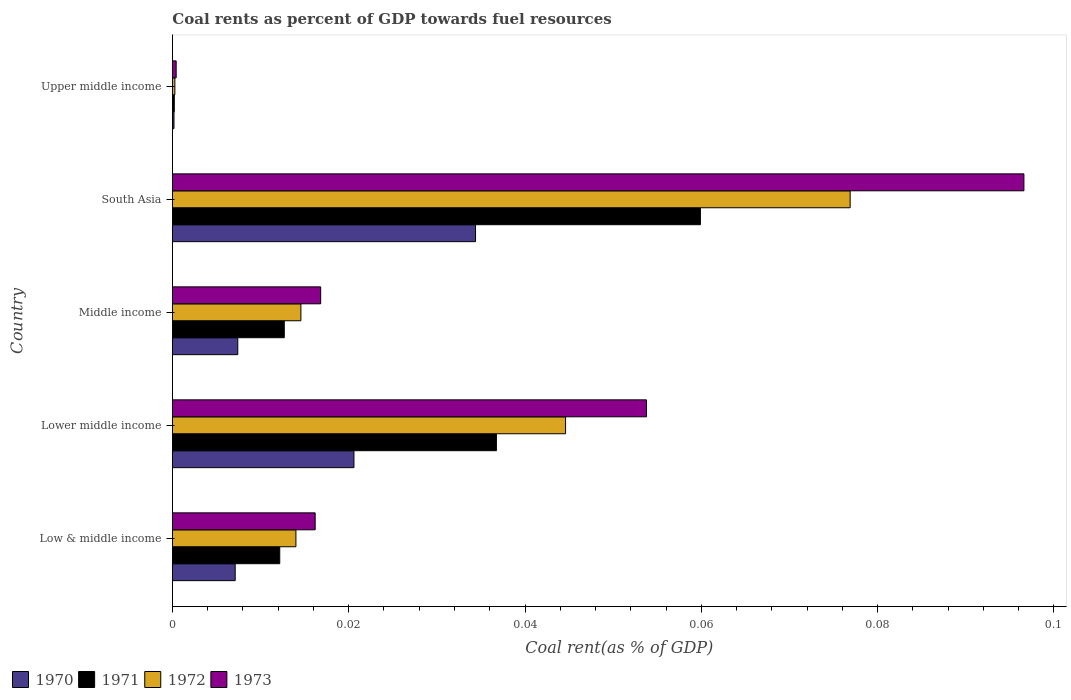How many different coloured bars are there?
Give a very brief answer. 4. In how many cases, is the number of bars for a given country not equal to the number of legend labels?
Your answer should be compact. 0. What is the coal rent in 1973 in Lower middle income?
Provide a succinct answer. 0.05. Across all countries, what is the maximum coal rent in 1970?
Offer a terse response. 0.03. Across all countries, what is the minimum coal rent in 1973?
Ensure brevity in your answer.  0. In which country was the coal rent in 1972 maximum?
Provide a short and direct response. South Asia. In which country was the coal rent in 1971 minimum?
Give a very brief answer. Upper middle income. What is the total coal rent in 1970 in the graph?
Give a very brief answer. 0.07. What is the difference between the coal rent in 1970 in Low & middle income and that in South Asia?
Offer a very short reply. -0.03. What is the difference between the coal rent in 1972 in Lower middle income and the coal rent in 1971 in Middle income?
Ensure brevity in your answer.  0.03. What is the average coal rent in 1973 per country?
Your response must be concise. 0.04. What is the difference between the coal rent in 1973 and coal rent in 1971 in Lower middle income?
Provide a short and direct response. 0.02. In how many countries, is the coal rent in 1971 greater than 0.096 %?
Offer a terse response. 0. What is the ratio of the coal rent in 1972 in Low & middle income to that in South Asia?
Make the answer very short. 0.18. Is the difference between the coal rent in 1973 in Lower middle income and South Asia greater than the difference between the coal rent in 1971 in Lower middle income and South Asia?
Provide a short and direct response. No. What is the difference between the highest and the second highest coal rent in 1971?
Offer a terse response. 0.02. What is the difference between the highest and the lowest coal rent in 1972?
Give a very brief answer. 0.08. Is it the case that in every country, the sum of the coal rent in 1970 and coal rent in 1972 is greater than the sum of coal rent in 1973 and coal rent in 1971?
Your answer should be very brief. No. What does the 4th bar from the bottom in Middle income represents?
Give a very brief answer. 1973. Is it the case that in every country, the sum of the coal rent in 1973 and coal rent in 1971 is greater than the coal rent in 1972?
Your answer should be very brief. Yes. Are the values on the major ticks of X-axis written in scientific E-notation?
Your response must be concise. No. How are the legend labels stacked?
Give a very brief answer. Horizontal. What is the title of the graph?
Provide a short and direct response. Coal rents as percent of GDP towards fuel resources. Does "1970" appear as one of the legend labels in the graph?
Offer a very short reply. Yes. What is the label or title of the X-axis?
Make the answer very short. Coal rent(as % of GDP). What is the label or title of the Y-axis?
Offer a terse response. Country. What is the Coal rent(as % of GDP) of 1970 in Low & middle income?
Make the answer very short. 0.01. What is the Coal rent(as % of GDP) in 1971 in Low & middle income?
Provide a short and direct response. 0.01. What is the Coal rent(as % of GDP) of 1972 in Low & middle income?
Your answer should be compact. 0.01. What is the Coal rent(as % of GDP) of 1973 in Low & middle income?
Offer a terse response. 0.02. What is the Coal rent(as % of GDP) in 1970 in Lower middle income?
Make the answer very short. 0.02. What is the Coal rent(as % of GDP) in 1971 in Lower middle income?
Offer a very short reply. 0.04. What is the Coal rent(as % of GDP) in 1972 in Lower middle income?
Ensure brevity in your answer.  0.04. What is the Coal rent(as % of GDP) of 1973 in Lower middle income?
Give a very brief answer. 0.05. What is the Coal rent(as % of GDP) of 1970 in Middle income?
Your response must be concise. 0.01. What is the Coal rent(as % of GDP) of 1971 in Middle income?
Give a very brief answer. 0.01. What is the Coal rent(as % of GDP) in 1972 in Middle income?
Keep it short and to the point. 0.01. What is the Coal rent(as % of GDP) in 1973 in Middle income?
Make the answer very short. 0.02. What is the Coal rent(as % of GDP) of 1970 in South Asia?
Your response must be concise. 0.03. What is the Coal rent(as % of GDP) of 1971 in South Asia?
Ensure brevity in your answer.  0.06. What is the Coal rent(as % of GDP) in 1972 in South Asia?
Keep it short and to the point. 0.08. What is the Coal rent(as % of GDP) of 1973 in South Asia?
Ensure brevity in your answer.  0.1. What is the Coal rent(as % of GDP) in 1970 in Upper middle income?
Make the answer very short. 0. What is the Coal rent(as % of GDP) of 1971 in Upper middle income?
Provide a short and direct response. 0. What is the Coal rent(as % of GDP) in 1972 in Upper middle income?
Keep it short and to the point. 0. What is the Coal rent(as % of GDP) of 1973 in Upper middle income?
Make the answer very short. 0. Across all countries, what is the maximum Coal rent(as % of GDP) in 1970?
Ensure brevity in your answer.  0.03. Across all countries, what is the maximum Coal rent(as % of GDP) of 1971?
Give a very brief answer. 0.06. Across all countries, what is the maximum Coal rent(as % of GDP) of 1972?
Ensure brevity in your answer.  0.08. Across all countries, what is the maximum Coal rent(as % of GDP) of 1973?
Your answer should be very brief. 0.1. Across all countries, what is the minimum Coal rent(as % of GDP) of 1970?
Your response must be concise. 0. Across all countries, what is the minimum Coal rent(as % of GDP) in 1971?
Give a very brief answer. 0. Across all countries, what is the minimum Coal rent(as % of GDP) in 1972?
Keep it short and to the point. 0. Across all countries, what is the minimum Coal rent(as % of GDP) of 1973?
Make the answer very short. 0. What is the total Coal rent(as % of GDP) in 1970 in the graph?
Ensure brevity in your answer.  0.07. What is the total Coal rent(as % of GDP) of 1971 in the graph?
Your answer should be compact. 0.12. What is the total Coal rent(as % of GDP) of 1972 in the graph?
Your answer should be compact. 0.15. What is the total Coal rent(as % of GDP) of 1973 in the graph?
Offer a terse response. 0.18. What is the difference between the Coal rent(as % of GDP) in 1970 in Low & middle income and that in Lower middle income?
Provide a succinct answer. -0.01. What is the difference between the Coal rent(as % of GDP) of 1971 in Low & middle income and that in Lower middle income?
Keep it short and to the point. -0.02. What is the difference between the Coal rent(as % of GDP) of 1972 in Low & middle income and that in Lower middle income?
Make the answer very short. -0.03. What is the difference between the Coal rent(as % of GDP) of 1973 in Low & middle income and that in Lower middle income?
Offer a terse response. -0.04. What is the difference between the Coal rent(as % of GDP) in 1970 in Low & middle income and that in Middle income?
Your answer should be very brief. -0. What is the difference between the Coal rent(as % of GDP) of 1971 in Low & middle income and that in Middle income?
Provide a succinct answer. -0. What is the difference between the Coal rent(as % of GDP) in 1972 in Low & middle income and that in Middle income?
Your answer should be very brief. -0. What is the difference between the Coal rent(as % of GDP) of 1973 in Low & middle income and that in Middle income?
Your response must be concise. -0. What is the difference between the Coal rent(as % of GDP) of 1970 in Low & middle income and that in South Asia?
Keep it short and to the point. -0.03. What is the difference between the Coal rent(as % of GDP) of 1971 in Low & middle income and that in South Asia?
Keep it short and to the point. -0.05. What is the difference between the Coal rent(as % of GDP) in 1972 in Low & middle income and that in South Asia?
Your answer should be compact. -0.06. What is the difference between the Coal rent(as % of GDP) in 1973 in Low & middle income and that in South Asia?
Offer a very short reply. -0.08. What is the difference between the Coal rent(as % of GDP) in 1970 in Low & middle income and that in Upper middle income?
Ensure brevity in your answer.  0.01. What is the difference between the Coal rent(as % of GDP) in 1971 in Low & middle income and that in Upper middle income?
Your response must be concise. 0.01. What is the difference between the Coal rent(as % of GDP) in 1972 in Low & middle income and that in Upper middle income?
Keep it short and to the point. 0.01. What is the difference between the Coal rent(as % of GDP) in 1973 in Low & middle income and that in Upper middle income?
Ensure brevity in your answer.  0.02. What is the difference between the Coal rent(as % of GDP) of 1970 in Lower middle income and that in Middle income?
Make the answer very short. 0.01. What is the difference between the Coal rent(as % of GDP) in 1971 in Lower middle income and that in Middle income?
Give a very brief answer. 0.02. What is the difference between the Coal rent(as % of GDP) of 1973 in Lower middle income and that in Middle income?
Give a very brief answer. 0.04. What is the difference between the Coal rent(as % of GDP) of 1970 in Lower middle income and that in South Asia?
Provide a succinct answer. -0.01. What is the difference between the Coal rent(as % of GDP) of 1971 in Lower middle income and that in South Asia?
Offer a terse response. -0.02. What is the difference between the Coal rent(as % of GDP) in 1972 in Lower middle income and that in South Asia?
Your answer should be very brief. -0.03. What is the difference between the Coal rent(as % of GDP) of 1973 in Lower middle income and that in South Asia?
Keep it short and to the point. -0.04. What is the difference between the Coal rent(as % of GDP) in 1970 in Lower middle income and that in Upper middle income?
Keep it short and to the point. 0.02. What is the difference between the Coal rent(as % of GDP) in 1971 in Lower middle income and that in Upper middle income?
Your answer should be compact. 0.04. What is the difference between the Coal rent(as % of GDP) in 1972 in Lower middle income and that in Upper middle income?
Provide a succinct answer. 0.04. What is the difference between the Coal rent(as % of GDP) of 1973 in Lower middle income and that in Upper middle income?
Offer a very short reply. 0.05. What is the difference between the Coal rent(as % of GDP) in 1970 in Middle income and that in South Asia?
Your response must be concise. -0.03. What is the difference between the Coal rent(as % of GDP) of 1971 in Middle income and that in South Asia?
Your response must be concise. -0.05. What is the difference between the Coal rent(as % of GDP) in 1972 in Middle income and that in South Asia?
Provide a short and direct response. -0.06. What is the difference between the Coal rent(as % of GDP) in 1973 in Middle income and that in South Asia?
Your response must be concise. -0.08. What is the difference between the Coal rent(as % of GDP) of 1970 in Middle income and that in Upper middle income?
Make the answer very short. 0.01. What is the difference between the Coal rent(as % of GDP) of 1971 in Middle income and that in Upper middle income?
Ensure brevity in your answer.  0.01. What is the difference between the Coal rent(as % of GDP) of 1972 in Middle income and that in Upper middle income?
Offer a very short reply. 0.01. What is the difference between the Coal rent(as % of GDP) of 1973 in Middle income and that in Upper middle income?
Your response must be concise. 0.02. What is the difference between the Coal rent(as % of GDP) of 1970 in South Asia and that in Upper middle income?
Offer a terse response. 0.03. What is the difference between the Coal rent(as % of GDP) in 1971 in South Asia and that in Upper middle income?
Provide a succinct answer. 0.06. What is the difference between the Coal rent(as % of GDP) in 1972 in South Asia and that in Upper middle income?
Ensure brevity in your answer.  0.08. What is the difference between the Coal rent(as % of GDP) of 1973 in South Asia and that in Upper middle income?
Provide a succinct answer. 0.1. What is the difference between the Coal rent(as % of GDP) in 1970 in Low & middle income and the Coal rent(as % of GDP) in 1971 in Lower middle income?
Your response must be concise. -0.03. What is the difference between the Coal rent(as % of GDP) of 1970 in Low & middle income and the Coal rent(as % of GDP) of 1972 in Lower middle income?
Make the answer very short. -0.04. What is the difference between the Coal rent(as % of GDP) of 1970 in Low & middle income and the Coal rent(as % of GDP) of 1973 in Lower middle income?
Ensure brevity in your answer.  -0.05. What is the difference between the Coal rent(as % of GDP) in 1971 in Low & middle income and the Coal rent(as % of GDP) in 1972 in Lower middle income?
Provide a short and direct response. -0.03. What is the difference between the Coal rent(as % of GDP) in 1971 in Low & middle income and the Coal rent(as % of GDP) in 1973 in Lower middle income?
Provide a succinct answer. -0.04. What is the difference between the Coal rent(as % of GDP) of 1972 in Low & middle income and the Coal rent(as % of GDP) of 1973 in Lower middle income?
Your answer should be very brief. -0.04. What is the difference between the Coal rent(as % of GDP) of 1970 in Low & middle income and the Coal rent(as % of GDP) of 1971 in Middle income?
Your response must be concise. -0.01. What is the difference between the Coal rent(as % of GDP) of 1970 in Low & middle income and the Coal rent(as % of GDP) of 1972 in Middle income?
Your response must be concise. -0.01. What is the difference between the Coal rent(as % of GDP) in 1970 in Low & middle income and the Coal rent(as % of GDP) in 1973 in Middle income?
Provide a short and direct response. -0.01. What is the difference between the Coal rent(as % of GDP) of 1971 in Low & middle income and the Coal rent(as % of GDP) of 1972 in Middle income?
Give a very brief answer. -0. What is the difference between the Coal rent(as % of GDP) in 1971 in Low & middle income and the Coal rent(as % of GDP) in 1973 in Middle income?
Provide a succinct answer. -0. What is the difference between the Coal rent(as % of GDP) in 1972 in Low & middle income and the Coal rent(as % of GDP) in 1973 in Middle income?
Your answer should be very brief. -0. What is the difference between the Coal rent(as % of GDP) in 1970 in Low & middle income and the Coal rent(as % of GDP) in 1971 in South Asia?
Your answer should be very brief. -0.05. What is the difference between the Coal rent(as % of GDP) of 1970 in Low & middle income and the Coal rent(as % of GDP) of 1972 in South Asia?
Ensure brevity in your answer.  -0.07. What is the difference between the Coal rent(as % of GDP) in 1970 in Low & middle income and the Coal rent(as % of GDP) in 1973 in South Asia?
Offer a terse response. -0.09. What is the difference between the Coal rent(as % of GDP) of 1971 in Low & middle income and the Coal rent(as % of GDP) of 1972 in South Asia?
Offer a very short reply. -0.06. What is the difference between the Coal rent(as % of GDP) in 1971 in Low & middle income and the Coal rent(as % of GDP) in 1973 in South Asia?
Make the answer very short. -0.08. What is the difference between the Coal rent(as % of GDP) in 1972 in Low & middle income and the Coal rent(as % of GDP) in 1973 in South Asia?
Ensure brevity in your answer.  -0.08. What is the difference between the Coal rent(as % of GDP) of 1970 in Low & middle income and the Coal rent(as % of GDP) of 1971 in Upper middle income?
Offer a terse response. 0.01. What is the difference between the Coal rent(as % of GDP) of 1970 in Low & middle income and the Coal rent(as % of GDP) of 1972 in Upper middle income?
Your answer should be compact. 0.01. What is the difference between the Coal rent(as % of GDP) of 1970 in Low & middle income and the Coal rent(as % of GDP) of 1973 in Upper middle income?
Your answer should be very brief. 0.01. What is the difference between the Coal rent(as % of GDP) in 1971 in Low & middle income and the Coal rent(as % of GDP) in 1972 in Upper middle income?
Provide a short and direct response. 0.01. What is the difference between the Coal rent(as % of GDP) in 1971 in Low & middle income and the Coal rent(as % of GDP) in 1973 in Upper middle income?
Your answer should be very brief. 0.01. What is the difference between the Coal rent(as % of GDP) in 1972 in Low & middle income and the Coal rent(as % of GDP) in 1973 in Upper middle income?
Provide a short and direct response. 0.01. What is the difference between the Coal rent(as % of GDP) of 1970 in Lower middle income and the Coal rent(as % of GDP) of 1971 in Middle income?
Offer a terse response. 0.01. What is the difference between the Coal rent(as % of GDP) in 1970 in Lower middle income and the Coal rent(as % of GDP) in 1972 in Middle income?
Make the answer very short. 0.01. What is the difference between the Coal rent(as % of GDP) in 1970 in Lower middle income and the Coal rent(as % of GDP) in 1973 in Middle income?
Keep it short and to the point. 0. What is the difference between the Coal rent(as % of GDP) in 1971 in Lower middle income and the Coal rent(as % of GDP) in 1972 in Middle income?
Give a very brief answer. 0.02. What is the difference between the Coal rent(as % of GDP) in 1971 in Lower middle income and the Coal rent(as % of GDP) in 1973 in Middle income?
Your answer should be very brief. 0.02. What is the difference between the Coal rent(as % of GDP) in 1972 in Lower middle income and the Coal rent(as % of GDP) in 1973 in Middle income?
Offer a terse response. 0.03. What is the difference between the Coal rent(as % of GDP) of 1970 in Lower middle income and the Coal rent(as % of GDP) of 1971 in South Asia?
Your answer should be compact. -0.04. What is the difference between the Coal rent(as % of GDP) in 1970 in Lower middle income and the Coal rent(as % of GDP) in 1972 in South Asia?
Your answer should be compact. -0.06. What is the difference between the Coal rent(as % of GDP) of 1970 in Lower middle income and the Coal rent(as % of GDP) of 1973 in South Asia?
Your response must be concise. -0.08. What is the difference between the Coal rent(as % of GDP) of 1971 in Lower middle income and the Coal rent(as % of GDP) of 1972 in South Asia?
Your answer should be compact. -0.04. What is the difference between the Coal rent(as % of GDP) of 1971 in Lower middle income and the Coal rent(as % of GDP) of 1973 in South Asia?
Keep it short and to the point. -0.06. What is the difference between the Coal rent(as % of GDP) in 1972 in Lower middle income and the Coal rent(as % of GDP) in 1973 in South Asia?
Offer a terse response. -0.05. What is the difference between the Coal rent(as % of GDP) of 1970 in Lower middle income and the Coal rent(as % of GDP) of 1971 in Upper middle income?
Ensure brevity in your answer.  0.02. What is the difference between the Coal rent(as % of GDP) of 1970 in Lower middle income and the Coal rent(as % of GDP) of 1972 in Upper middle income?
Offer a terse response. 0.02. What is the difference between the Coal rent(as % of GDP) in 1970 in Lower middle income and the Coal rent(as % of GDP) in 1973 in Upper middle income?
Provide a short and direct response. 0.02. What is the difference between the Coal rent(as % of GDP) in 1971 in Lower middle income and the Coal rent(as % of GDP) in 1972 in Upper middle income?
Provide a succinct answer. 0.04. What is the difference between the Coal rent(as % of GDP) in 1971 in Lower middle income and the Coal rent(as % of GDP) in 1973 in Upper middle income?
Ensure brevity in your answer.  0.04. What is the difference between the Coal rent(as % of GDP) of 1972 in Lower middle income and the Coal rent(as % of GDP) of 1973 in Upper middle income?
Make the answer very short. 0.04. What is the difference between the Coal rent(as % of GDP) in 1970 in Middle income and the Coal rent(as % of GDP) in 1971 in South Asia?
Give a very brief answer. -0.05. What is the difference between the Coal rent(as % of GDP) in 1970 in Middle income and the Coal rent(as % of GDP) in 1972 in South Asia?
Provide a short and direct response. -0.07. What is the difference between the Coal rent(as % of GDP) in 1970 in Middle income and the Coal rent(as % of GDP) in 1973 in South Asia?
Your answer should be compact. -0.09. What is the difference between the Coal rent(as % of GDP) of 1971 in Middle income and the Coal rent(as % of GDP) of 1972 in South Asia?
Your answer should be compact. -0.06. What is the difference between the Coal rent(as % of GDP) of 1971 in Middle income and the Coal rent(as % of GDP) of 1973 in South Asia?
Your answer should be compact. -0.08. What is the difference between the Coal rent(as % of GDP) in 1972 in Middle income and the Coal rent(as % of GDP) in 1973 in South Asia?
Ensure brevity in your answer.  -0.08. What is the difference between the Coal rent(as % of GDP) in 1970 in Middle income and the Coal rent(as % of GDP) in 1971 in Upper middle income?
Ensure brevity in your answer.  0.01. What is the difference between the Coal rent(as % of GDP) in 1970 in Middle income and the Coal rent(as % of GDP) in 1972 in Upper middle income?
Give a very brief answer. 0.01. What is the difference between the Coal rent(as % of GDP) in 1970 in Middle income and the Coal rent(as % of GDP) in 1973 in Upper middle income?
Give a very brief answer. 0.01. What is the difference between the Coal rent(as % of GDP) in 1971 in Middle income and the Coal rent(as % of GDP) in 1972 in Upper middle income?
Keep it short and to the point. 0.01. What is the difference between the Coal rent(as % of GDP) in 1971 in Middle income and the Coal rent(as % of GDP) in 1973 in Upper middle income?
Make the answer very short. 0.01. What is the difference between the Coal rent(as % of GDP) in 1972 in Middle income and the Coal rent(as % of GDP) in 1973 in Upper middle income?
Offer a very short reply. 0.01. What is the difference between the Coal rent(as % of GDP) of 1970 in South Asia and the Coal rent(as % of GDP) of 1971 in Upper middle income?
Your answer should be compact. 0.03. What is the difference between the Coal rent(as % of GDP) in 1970 in South Asia and the Coal rent(as % of GDP) in 1972 in Upper middle income?
Your response must be concise. 0.03. What is the difference between the Coal rent(as % of GDP) of 1970 in South Asia and the Coal rent(as % of GDP) of 1973 in Upper middle income?
Ensure brevity in your answer.  0.03. What is the difference between the Coal rent(as % of GDP) of 1971 in South Asia and the Coal rent(as % of GDP) of 1972 in Upper middle income?
Your answer should be compact. 0.06. What is the difference between the Coal rent(as % of GDP) of 1971 in South Asia and the Coal rent(as % of GDP) of 1973 in Upper middle income?
Your response must be concise. 0.06. What is the difference between the Coal rent(as % of GDP) of 1972 in South Asia and the Coal rent(as % of GDP) of 1973 in Upper middle income?
Provide a succinct answer. 0.08. What is the average Coal rent(as % of GDP) in 1970 per country?
Make the answer very short. 0.01. What is the average Coal rent(as % of GDP) in 1971 per country?
Your answer should be compact. 0.02. What is the average Coal rent(as % of GDP) in 1972 per country?
Offer a terse response. 0.03. What is the average Coal rent(as % of GDP) in 1973 per country?
Ensure brevity in your answer.  0.04. What is the difference between the Coal rent(as % of GDP) of 1970 and Coal rent(as % of GDP) of 1971 in Low & middle income?
Give a very brief answer. -0.01. What is the difference between the Coal rent(as % of GDP) of 1970 and Coal rent(as % of GDP) of 1972 in Low & middle income?
Give a very brief answer. -0.01. What is the difference between the Coal rent(as % of GDP) in 1970 and Coal rent(as % of GDP) in 1973 in Low & middle income?
Provide a short and direct response. -0.01. What is the difference between the Coal rent(as % of GDP) in 1971 and Coal rent(as % of GDP) in 1972 in Low & middle income?
Offer a terse response. -0. What is the difference between the Coal rent(as % of GDP) of 1971 and Coal rent(as % of GDP) of 1973 in Low & middle income?
Make the answer very short. -0. What is the difference between the Coal rent(as % of GDP) in 1972 and Coal rent(as % of GDP) in 1973 in Low & middle income?
Your answer should be very brief. -0. What is the difference between the Coal rent(as % of GDP) of 1970 and Coal rent(as % of GDP) of 1971 in Lower middle income?
Provide a short and direct response. -0.02. What is the difference between the Coal rent(as % of GDP) in 1970 and Coal rent(as % of GDP) in 1972 in Lower middle income?
Give a very brief answer. -0.02. What is the difference between the Coal rent(as % of GDP) in 1970 and Coal rent(as % of GDP) in 1973 in Lower middle income?
Provide a succinct answer. -0.03. What is the difference between the Coal rent(as % of GDP) of 1971 and Coal rent(as % of GDP) of 1972 in Lower middle income?
Keep it short and to the point. -0.01. What is the difference between the Coal rent(as % of GDP) in 1971 and Coal rent(as % of GDP) in 1973 in Lower middle income?
Offer a very short reply. -0.02. What is the difference between the Coal rent(as % of GDP) in 1972 and Coal rent(as % of GDP) in 1973 in Lower middle income?
Offer a terse response. -0.01. What is the difference between the Coal rent(as % of GDP) of 1970 and Coal rent(as % of GDP) of 1971 in Middle income?
Provide a short and direct response. -0.01. What is the difference between the Coal rent(as % of GDP) of 1970 and Coal rent(as % of GDP) of 1972 in Middle income?
Offer a very short reply. -0.01. What is the difference between the Coal rent(as % of GDP) of 1970 and Coal rent(as % of GDP) of 1973 in Middle income?
Provide a succinct answer. -0.01. What is the difference between the Coal rent(as % of GDP) in 1971 and Coal rent(as % of GDP) in 1972 in Middle income?
Your answer should be very brief. -0. What is the difference between the Coal rent(as % of GDP) in 1971 and Coal rent(as % of GDP) in 1973 in Middle income?
Offer a terse response. -0. What is the difference between the Coal rent(as % of GDP) in 1972 and Coal rent(as % of GDP) in 1973 in Middle income?
Make the answer very short. -0. What is the difference between the Coal rent(as % of GDP) of 1970 and Coal rent(as % of GDP) of 1971 in South Asia?
Offer a very short reply. -0.03. What is the difference between the Coal rent(as % of GDP) of 1970 and Coal rent(as % of GDP) of 1972 in South Asia?
Ensure brevity in your answer.  -0.04. What is the difference between the Coal rent(as % of GDP) of 1970 and Coal rent(as % of GDP) of 1973 in South Asia?
Offer a very short reply. -0.06. What is the difference between the Coal rent(as % of GDP) of 1971 and Coal rent(as % of GDP) of 1972 in South Asia?
Offer a terse response. -0.02. What is the difference between the Coal rent(as % of GDP) of 1971 and Coal rent(as % of GDP) of 1973 in South Asia?
Provide a short and direct response. -0.04. What is the difference between the Coal rent(as % of GDP) of 1972 and Coal rent(as % of GDP) of 1973 in South Asia?
Offer a very short reply. -0.02. What is the difference between the Coal rent(as % of GDP) in 1970 and Coal rent(as % of GDP) in 1971 in Upper middle income?
Offer a terse response. -0. What is the difference between the Coal rent(as % of GDP) in 1970 and Coal rent(as % of GDP) in 1972 in Upper middle income?
Offer a very short reply. -0. What is the difference between the Coal rent(as % of GDP) of 1970 and Coal rent(as % of GDP) of 1973 in Upper middle income?
Your answer should be very brief. -0. What is the difference between the Coal rent(as % of GDP) of 1971 and Coal rent(as % of GDP) of 1972 in Upper middle income?
Your response must be concise. -0. What is the difference between the Coal rent(as % of GDP) in 1971 and Coal rent(as % of GDP) in 1973 in Upper middle income?
Offer a very short reply. -0. What is the difference between the Coal rent(as % of GDP) of 1972 and Coal rent(as % of GDP) of 1973 in Upper middle income?
Your answer should be compact. -0. What is the ratio of the Coal rent(as % of GDP) in 1970 in Low & middle income to that in Lower middle income?
Make the answer very short. 0.35. What is the ratio of the Coal rent(as % of GDP) of 1971 in Low & middle income to that in Lower middle income?
Offer a very short reply. 0.33. What is the ratio of the Coal rent(as % of GDP) in 1972 in Low & middle income to that in Lower middle income?
Make the answer very short. 0.31. What is the ratio of the Coal rent(as % of GDP) in 1973 in Low & middle income to that in Lower middle income?
Keep it short and to the point. 0.3. What is the ratio of the Coal rent(as % of GDP) in 1970 in Low & middle income to that in Middle income?
Your response must be concise. 0.96. What is the ratio of the Coal rent(as % of GDP) in 1971 in Low & middle income to that in Middle income?
Offer a very short reply. 0.96. What is the ratio of the Coal rent(as % of GDP) of 1972 in Low & middle income to that in Middle income?
Ensure brevity in your answer.  0.96. What is the ratio of the Coal rent(as % of GDP) in 1973 in Low & middle income to that in Middle income?
Offer a very short reply. 0.96. What is the ratio of the Coal rent(as % of GDP) in 1970 in Low & middle income to that in South Asia?
Keep it short and to the point. 0.21. What is the ratio of the Coal rent(as % of GDP) in 1971 in Low & middle income to that in South Asia?
Provide a succinct answer. 0.2. What is the ratio of the Coal rent(as % of GDP) of 1972 in Low & middle income to that in South Asia?
Offer a very short reply. 0.18. What is the ratio of the Coal rent(as % of GDP) in 1973 in Low & middle income to that in South Asia?
Make the answer very short. 0.17. What is the ratio of the Coal rent(as % of GDP) of 1970 in Low & middle income to that in Upper middle income?
Keep it short and to the point. 38.77. What is the ratio of the Coal rent(as % of GDP) in 1971 in Low & middle income to that in Upper middle income?
Ensure brevity in your answer.  55.66. What is the ratio of the Coal rent(as % of GDP) in 1972 in Low & middle income to that in Upper middle income?
Your answer should be very brief. 49.28. What is the ratio of the Coal rent(as % of GDP) in 1973 in Low & middle income to that in Upper middle income?
Ensure brevity in your answer.  37.59. What is the ratio of the Coal rent(as % of GDP) of 1970 in Lower middle income to that in Middle income?
Make the answer very short. 2.78. What is the ratio of the Coal rent(as % of GDP) in 1971 in Lower middle income to that in Middle income?
Provide a short and direct response. 2.9. What is the ratio of the Coal rent(as % of GDP) of 1972 in Lower middle income to that in Middle income?
Your answer should be compact. 3.06. What is the ratio of the Coal rent(as % of GDP) in 1973 in Lower middle income to that in Middle income?
Your response must be concise. 3.2. What is the ratio of the Coal rent(as % of GDP) in 1970 in Lower middle income to that in South Asia?
Keep it short and to the point. 0.6. What is the ratio of the Coal rent(as % of GDP) in 1971 in Lower middle income to that in South Asia?
Make the answer very short. 0.61. What is the ratio of the Coal rent(as % of GDP) of 1972 in Lower middle income to that in South Asia?
Offer a terse response. 0.58. What is the ratio of the Coal rent(as % of GDP) of 1973 in Lower middle income to that in South Asia?
Offer a terse response. 0.56. What is the ratio of the Coal rent(as % of GDP) of 1970 in Lower middle income to that in Upper middle income?
Give a very brief answer. 112.03. What is the ratio of the Coal rent(as % of GDP) in 1971 in Lower middle income to that in Upper middle income?
Keep it short and to the point. 167.98. What is the ratio of the Coal rent(as % of GDP) of 1972 in Lower middle income to that in Upper middle income?
Provide a succinct answer. 156.82. What is the ratio of the Coal rent(as % of GDP) in 1973 in Lower middle income to that in Upper middle income?
Your response must be concise. 124.82. What is the ratio of the Coal rent(as % of GDP) of 1970 in Middle income to that in South Asia?
Offer a terse response. 0.22. What is the ratio of the Coal rent(as % of GDP) of 1971 in Middle income to that in South Asia?
Your answer should be compact. 0.21. What is the ratio of the Coal rent(as % of GDP) of 1972 in Middle income to that in South Asia?
Offer a very short reply. 0.19. What is the ratio of the Coal rent(as % of GDP) in 1973 in Middle income to that in South Asia?
Provide a succinct answer. 0.17. What is the ratio of the Coal rent(as % of GDP) in 1970 in Middle income to that in Upper middle income?
Offer a very short reply. 40.36. What is the ratio of the Coal rent(as % of GDP) in 1971 in Middle income to that in Upper middle income?
Offer a very short reply. 58.01. What is the ratio of the Coal rent(as % of GDP) of 1972 in Middle income to that in Upper middle income?
Make the answer very short. 51.25. What is the ratio of the Coal rent(as % of GDP) in 1973 in Middle income to that in Upper middle income?
Ensure brevity in your answer.  39.04. What is the ratio of the Coal rent(as % of GDP) of 1970 in South Asia to that in Upper middle income?
Your answer should be compact. 187.05. What is the ratio of the Coal rent(as % of GDP) in 1971 in South Asia to that in Upper middle income?
Offer a very short reply. 273.74. What is the ratio of the Coal rent(as % of GDP) of 1972 in South Asia to that in Upper middle income?
Provide a short and direct response. 270.32. What is the ratio of the Coal rent(as % of GDP) in 1973 in South Asia to that in Upper middle income?
Your response must be concise. 224.18. What is the difference between the highest and the second highest Coal rent(as % of GDP) in 1970?
Give a very brief answer. 0.01. What is the difference between the highest and the second highest Coal rent(as % of GDP) of 1971?
Offer a terse response. 0.02. What is the difference between the highest and the second highest Coal rent(as % of GDP) in 1972?
Your answer should be very brief. 0.03. What is the difference between the highest and the second highest Coal rent(as % of GDP) of 1973?
Keep it short and to the point. 0.04. What is the difference between the highest and the lowest Coal rent(as % of GDP) of 1970?
Your response must be concise. 0.03. What is the difference between the highest and the lowest Coal rent(as % of GDP) in 1971?
Keep it short and to the point. 0.06. What is the difference between the highest and the lowest Coal rent(as % of GDP) of 1972?
Keep it short and to the point. 0.08. What is the difference between the highest and the lowest Coal rent(as % of GDP) in 1973?
Give a very brief answer. 0.1. 